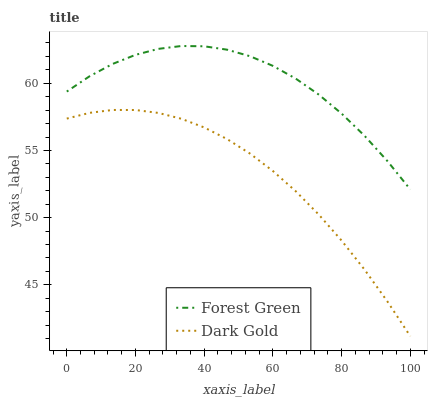Does Dark Gold have the minimum area under the curve?
Answer yes or no. Yes. Does Forest Green have the maximum area under the curve?
Answer yes or no. Yes. Does Dark Gold have the maximum area under the curve?
Answer yes or no. No. Is Dark Gold the smoothest?
Answer yes or no. Yes. Is Forest Green the roughest?
Answer yes or no. Yes. Is Dark Gold the roughest?
Answer yes or no. No. Does Dark Gold have the lowest value?
Answer yes or no. Yes. Does Forest Green have the highest value?
Answer yes or no. Yes. Does Dark Gold have the highest value?
Answer yes or no. No. Is Dark Gold less than Forest Green?
Answer yes or no. Yes. Is Forest Green greater than Dark Gold?
Answer yes or no. Yes. Does Dark Gold intersect Forest Green?
Answer yes or no. No. 